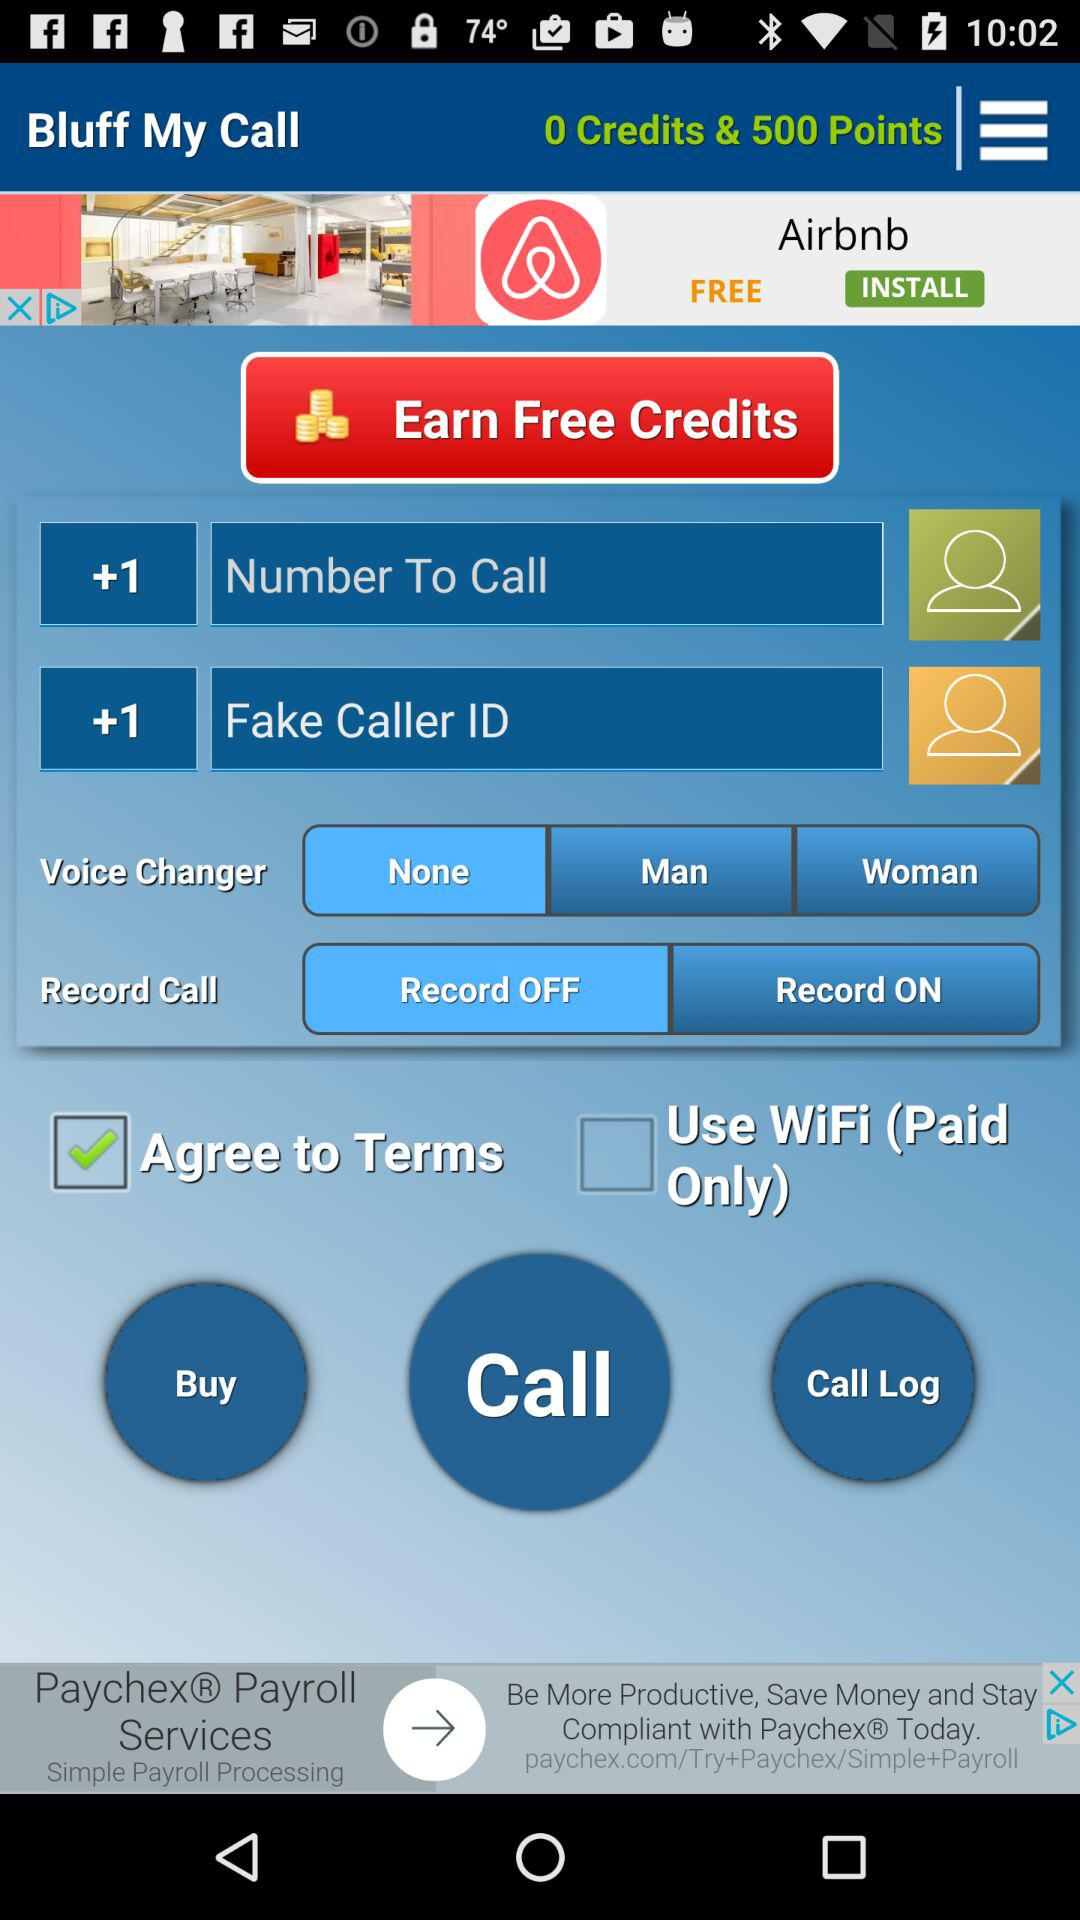Which option is selected in the Voice Changer?
Answer the question using a single word or phrase. The selected option is "None" 